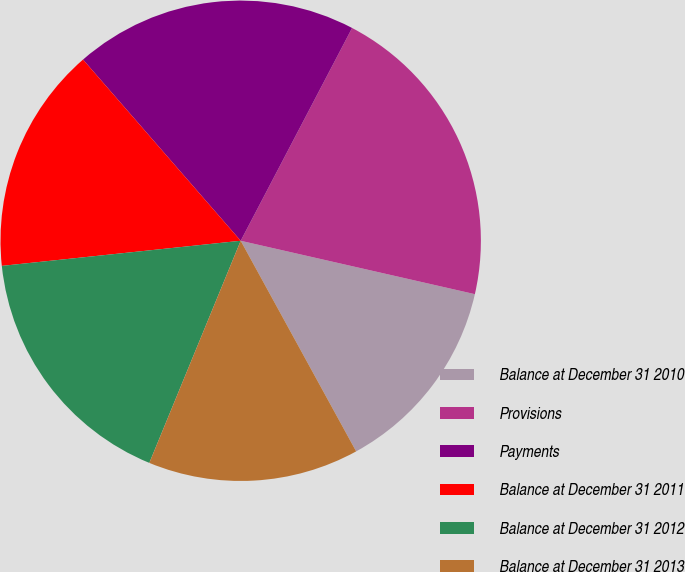Convert chart to OTSL. <chart><loc_0><loc_0><loc_500><loc_500><pie_chart><fcel>Balance at December 31 2010<fcel>Provisions<fcel>Payments<fcel>Balance at December 31 2011<fcel>Balance at December 31 2012<fcel>Balance at December 31 2013<nl><fcel>13.45%<fcel>20.89%<fcel>19.07%<fcel>15.27%<fcel>17.12%<fcel>14.19%<nl></chart> 